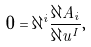Convert formula to latex. <formula><loc_0><loc_0><loc_500><loc_500>0 = \partial ^ { i } \frac { \partial A _ { i } } { \partial u ^ { I } } ,</formula> 